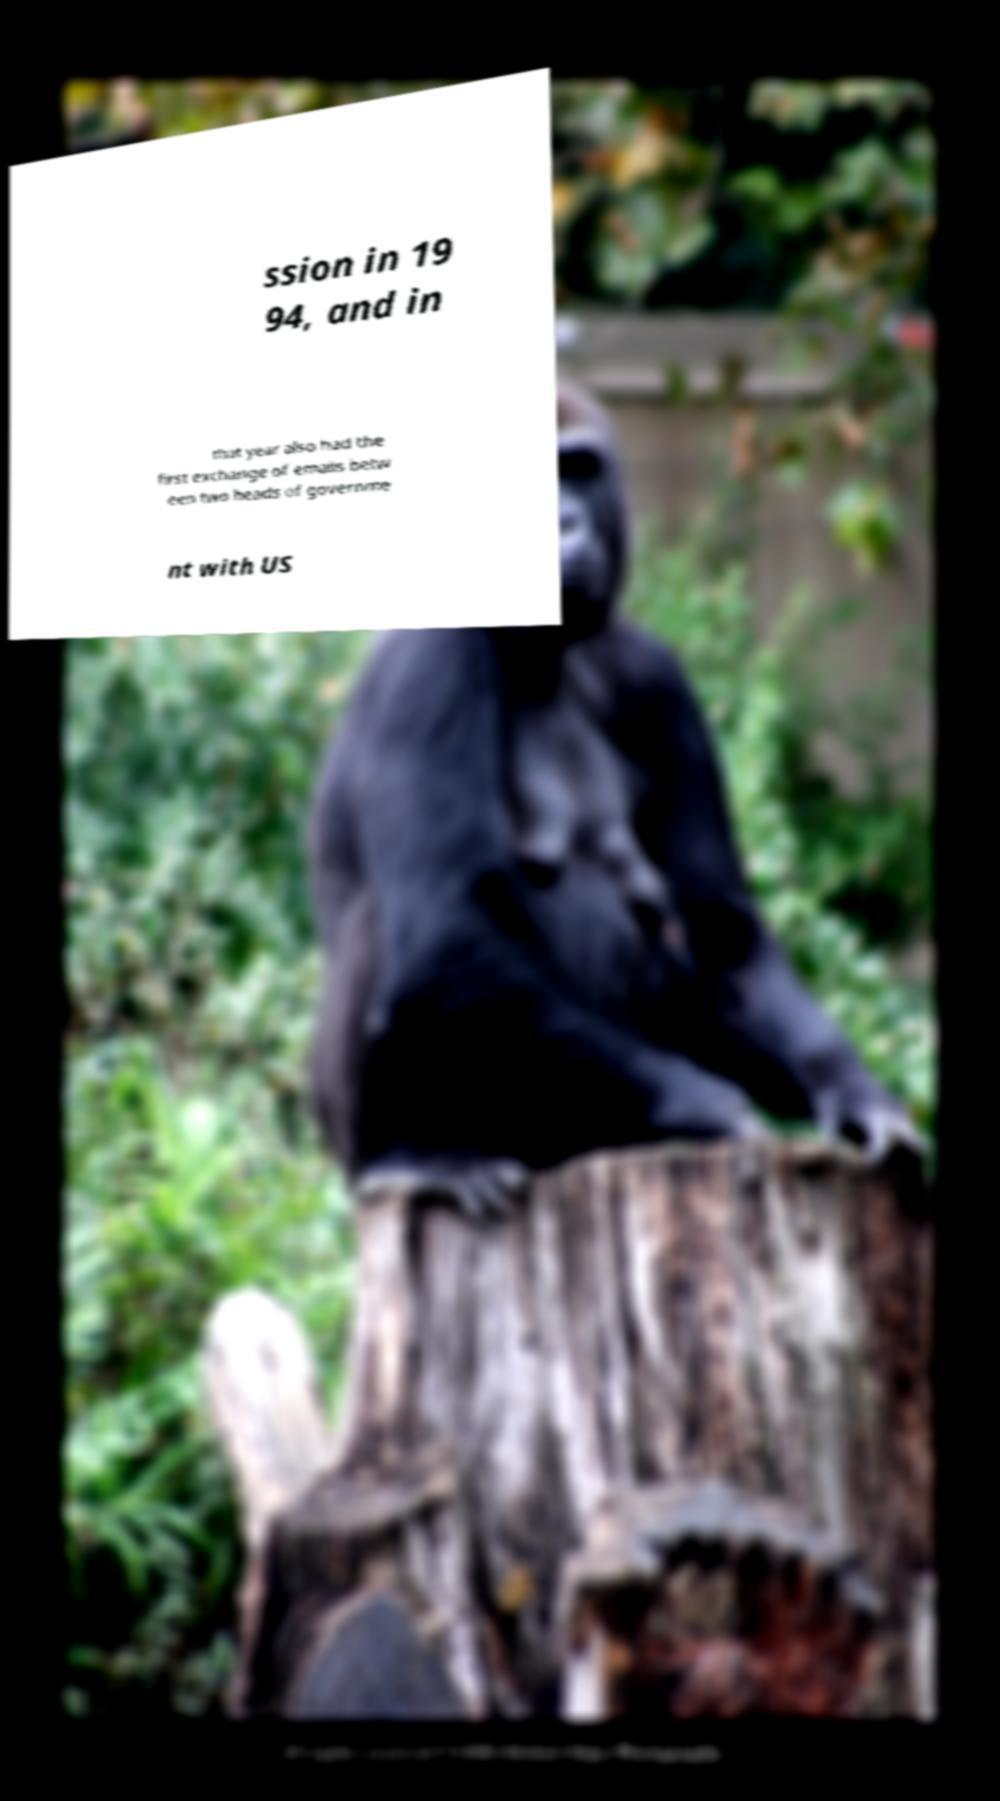What messages or text are displayed in this image? I need them in a readable, typed format. ssion in 19 94, and in that year also had the first exchange of emails betw een two heads of governme nt with US 